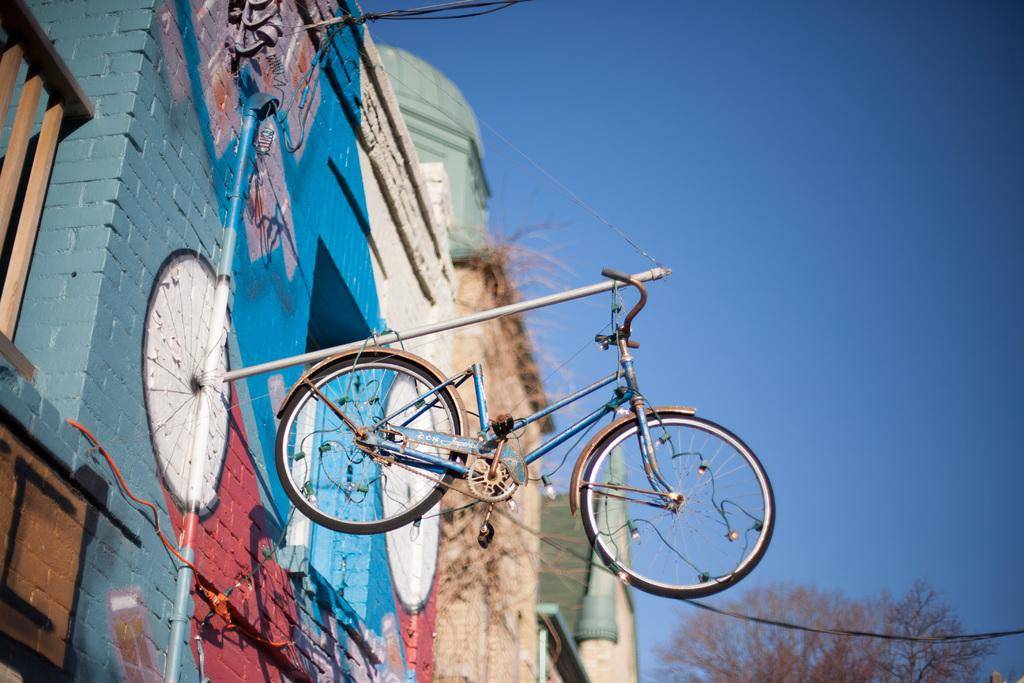What is hanging from the wire in the image? There is a bicycle on a wire in the image. What can be seen on the left side of the image? There are buildings on the left side of the image. What object is present in the image that is typically used for transporting fluids? There is a pipe in the image. What type of plant is visible at the back of the image? There is a tree at the back of the image. What is the chance of seeing frogs hopping on the pipe in the image? There are no frogs present in the image, so it is not possible to determine the chance of seeing them hopping on the pipe. 